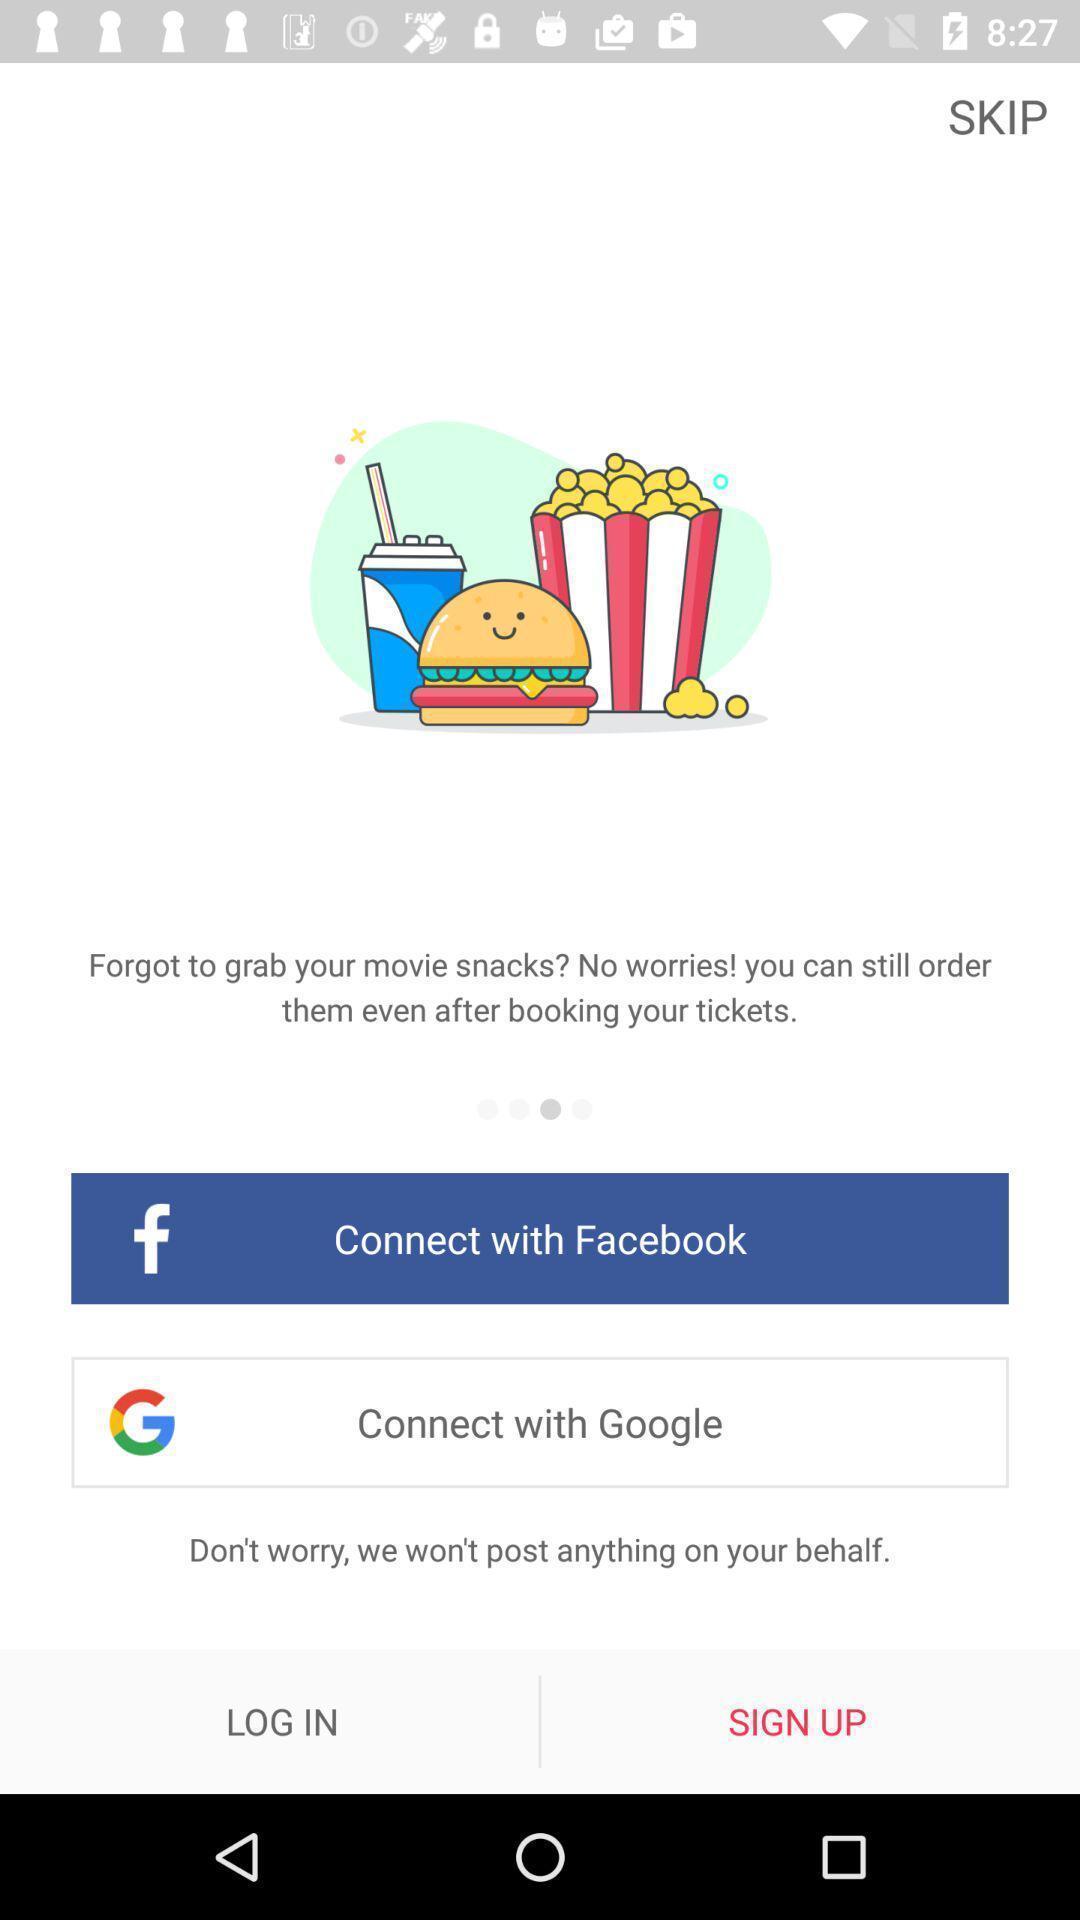Please provide a description for this image. Welcome to the sign in page. 